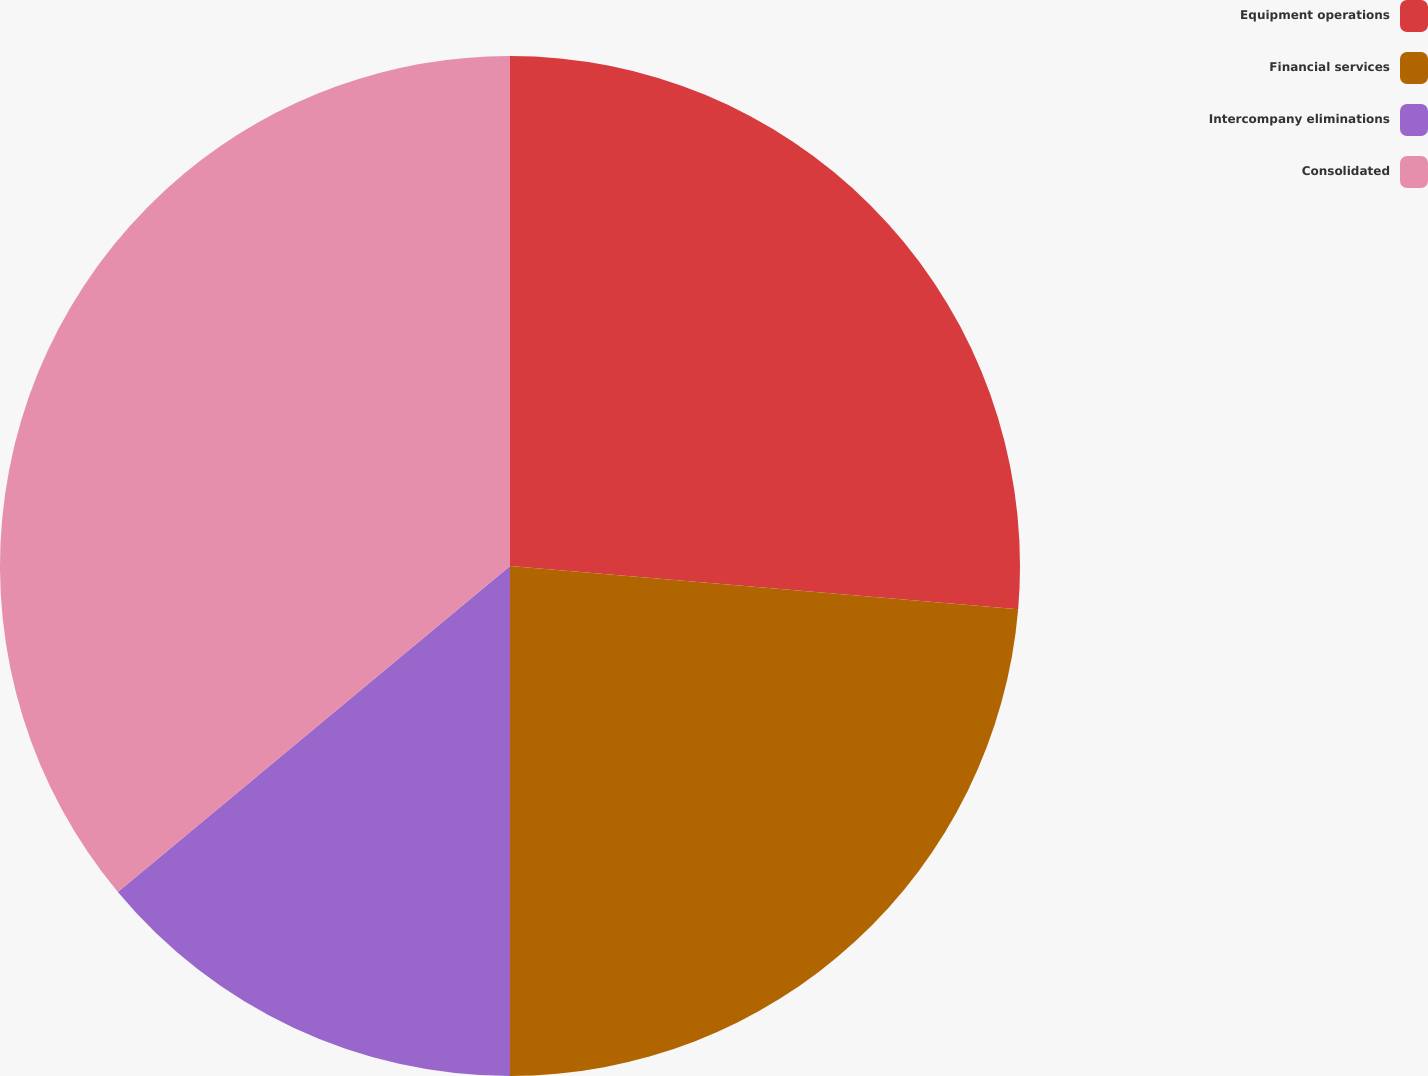Convert chart to OTSL. <chart><loc_0><loc_0><loc_500><loc_500><pie_chart><fcel>Equipment operations<fcel>Financial services<fcel>Intercompany eliminations<fcel>Consolidated<nl><fcel>26.35%<fcel>23.65%<fcel>13.96%<fcel>36.04%<nl></chart> 